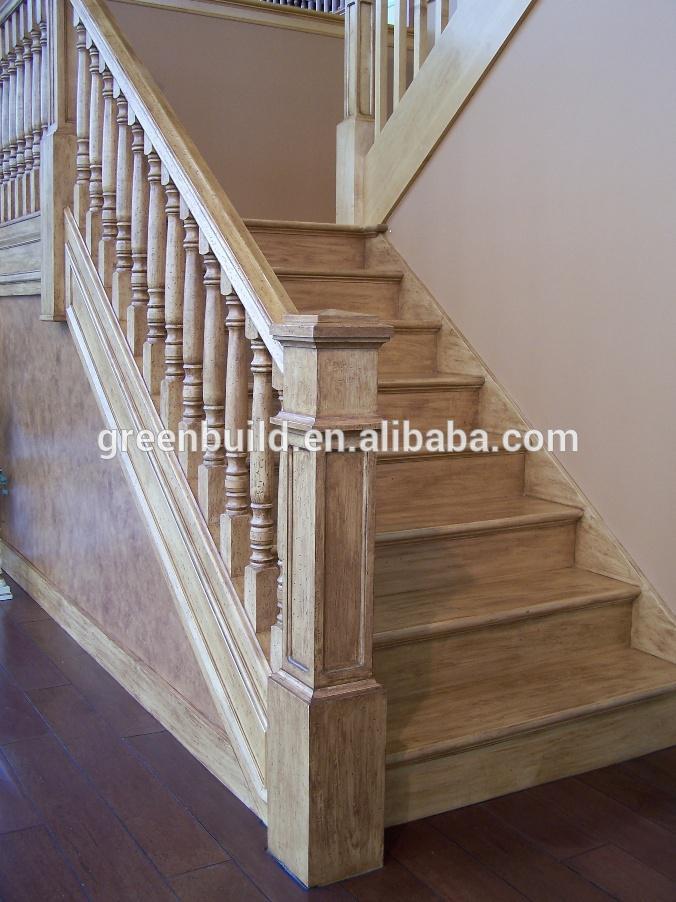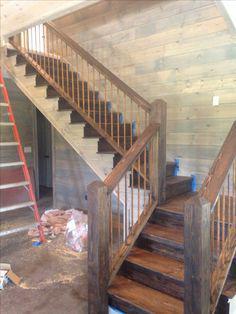The first image is the image on the left, the second image is the image on the right. For the images displayed, is the sentence "The left image shows a leftward-ascending staircase with a square light-colored wood-grain post at the bottom." factually correct? Answer yes or no. Yes. 